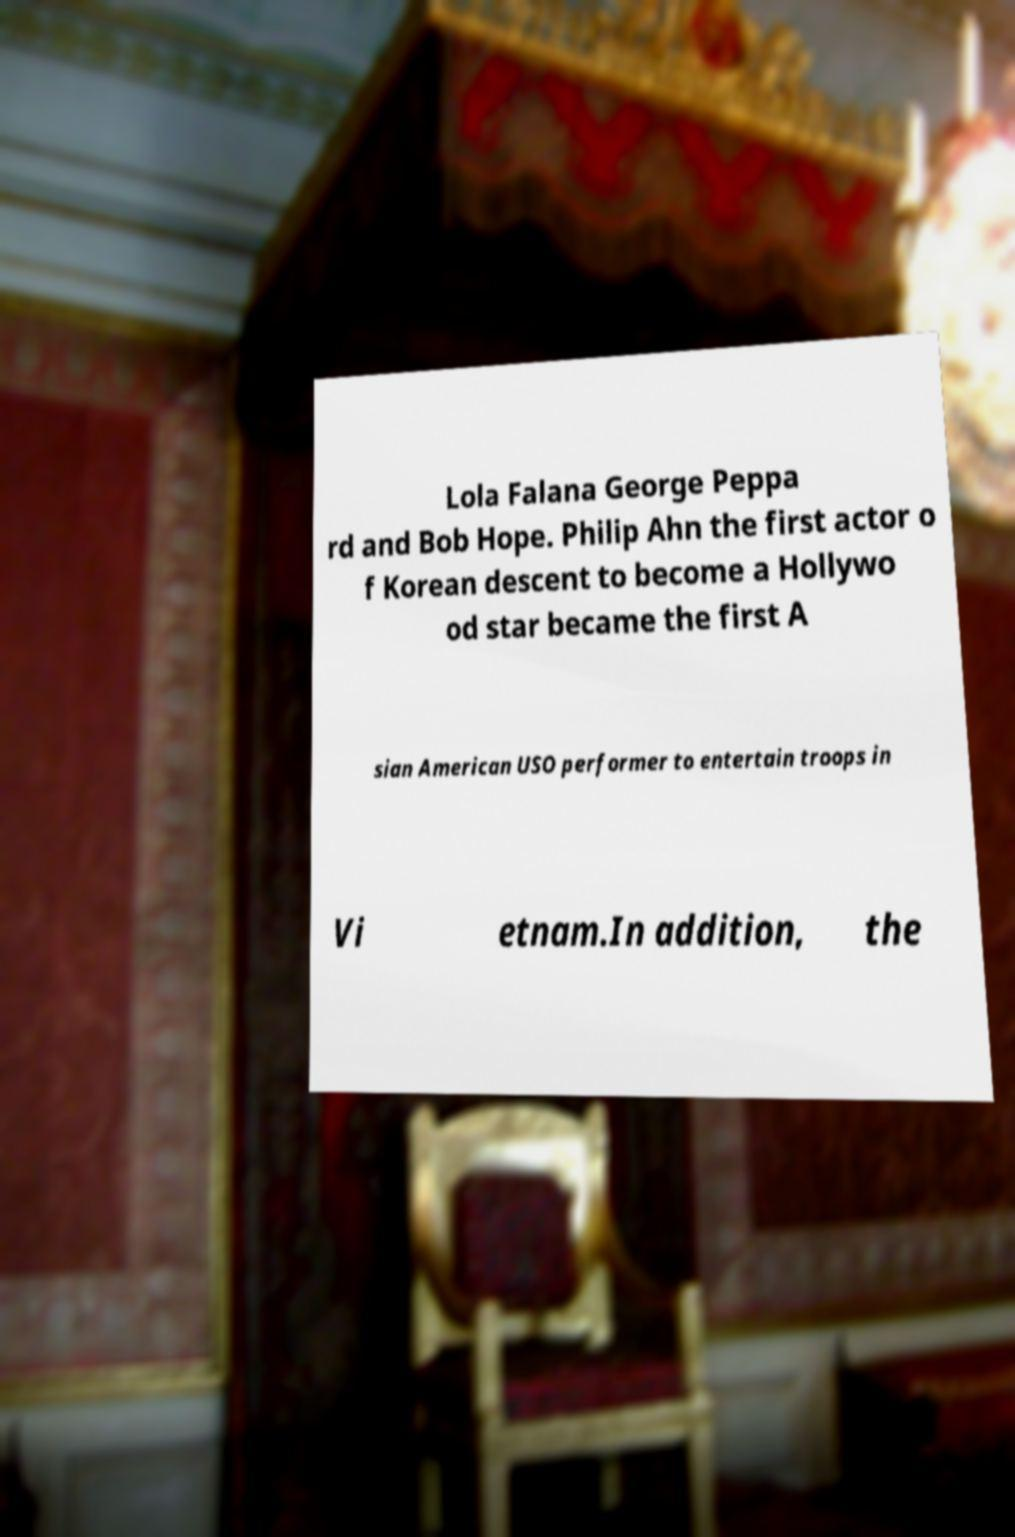For documentation purposes, I need the text within this image transcribed. Could you provide that? Lola Falana George Peppa rd and Bob Hope. Philip Ahn the first actor o f Korean descent to become a Hollywo od star became the first A sian American USO performer to entertain troops in Vi etnam.In addition, the 